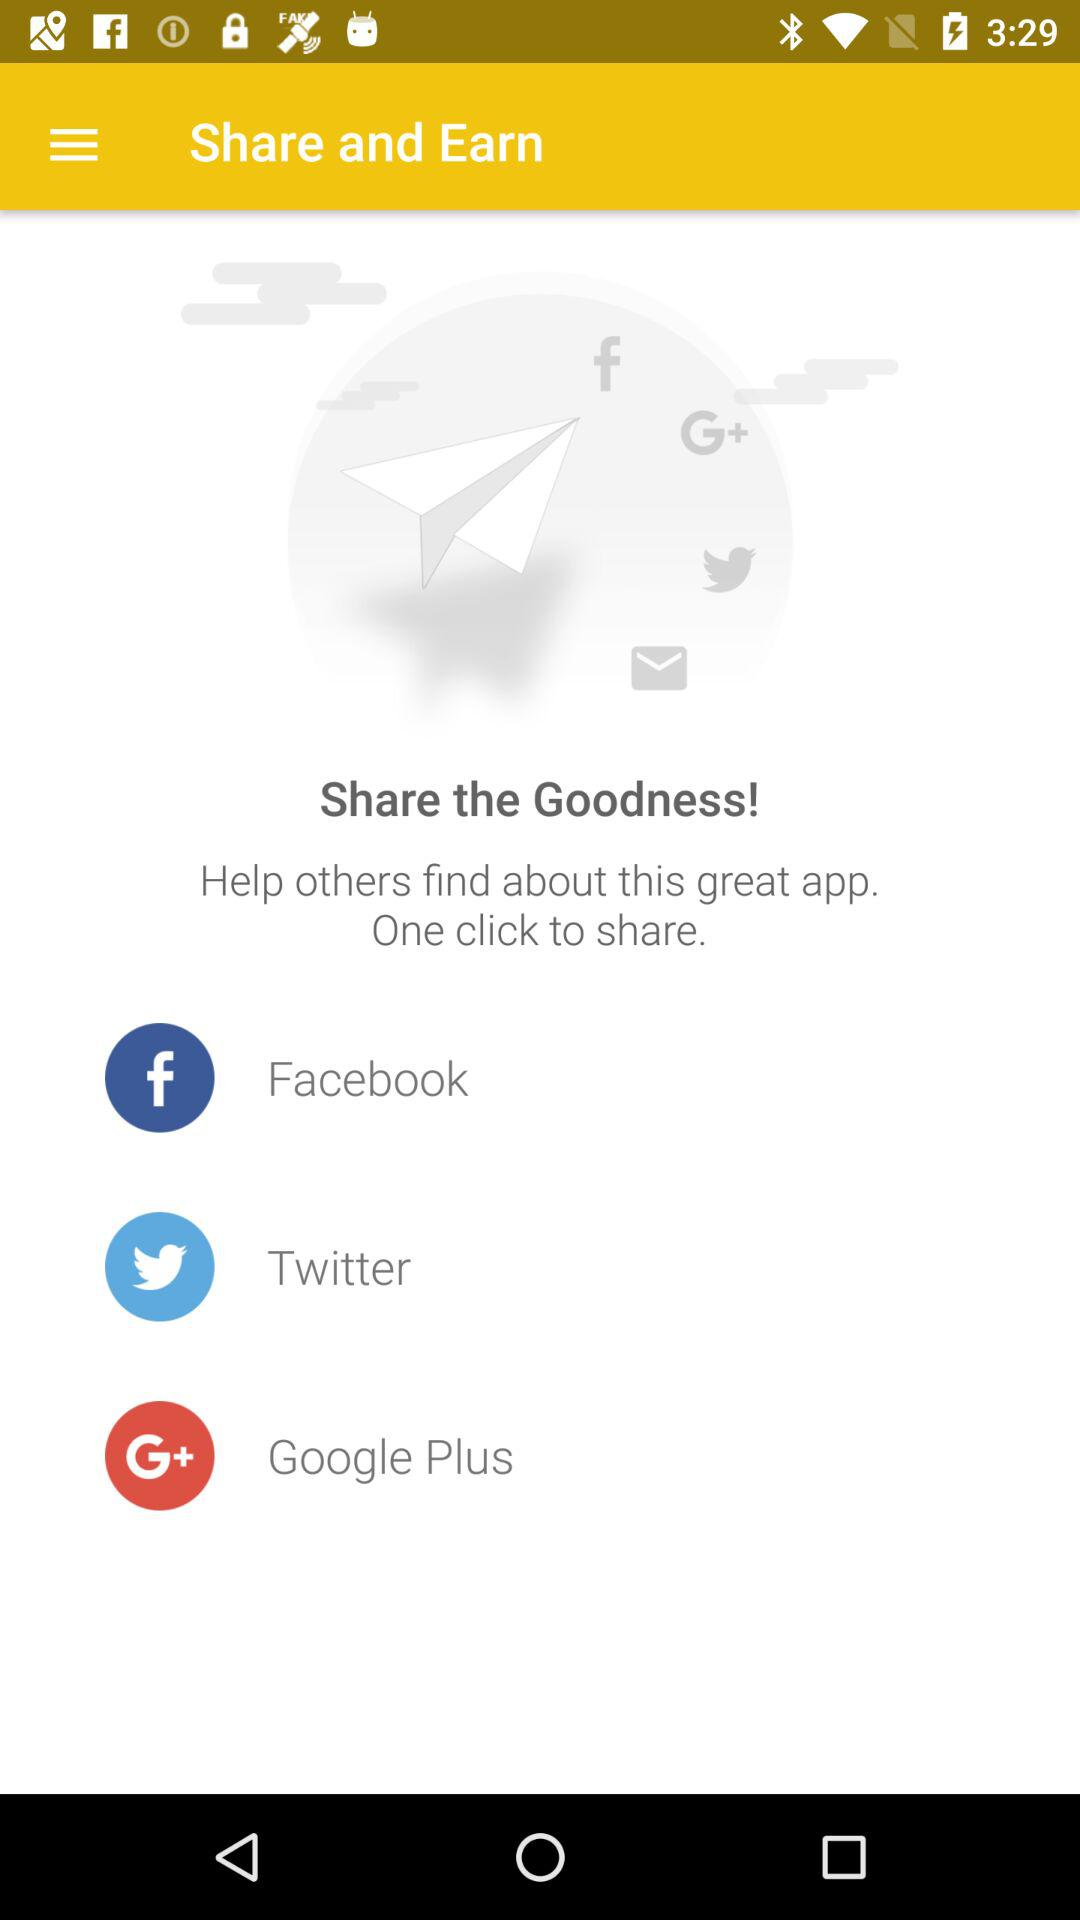How many social media platforms are available to share the app?
Answer the question using a single word or phrase. 3 